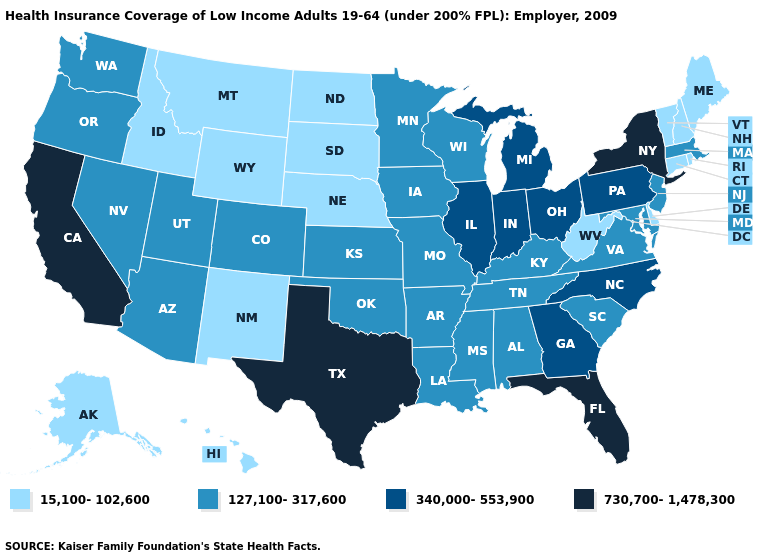Name the states that have a value in the range 730,700-1,478,300?
Be succinct. California, Florida, New York, Texas. What is the value of Mississippi?
Concise answer only. 127,100-317,600. Name the states that have a value in the range 730,700-1,478,300?
Quick response, please. California, Florida, New York, Texas. Which states have the lowest value in the USA?
Be succinct. Alaska, Connecticut, Delaware, Hawaii, Idaho, Maine, Montana, Nebraska, New Hampshire, New Mexico, North Dakota, Rhode Island, South Dakota, Vermont, West Virginia, Wyoming. Which states hav the highest value in the South?
Quick response, please. Florida, Texas. Among the states that border New Hampshire , which have the highest value?
Give a very brief answer. Massachusetts. Does Illinois have the highest value in the USA?
Keep it brief. No. What is the highest value in the South ?
Give a very brief answer. 730,700-1,478,300. What is the value of West Virginia?
Quick response, please. 15,100-102,600. What is the value of Alabama?
Short answer required. 127,100-317,600. What is the highest value in the USA?
Keep it brief. 730,700-1,478,300. Name the states that have a value in the range 127,100-317,600?
Be succinct. Alabama, Arizona, Arkansas, Colorado, Iowa, Kansas, Kentucky, Louisiana, Maryland, Massachusetts, Minnesota, Mississippi, Missouri, Nevada, New Jersey, Oklahoma, Oregon, South Carolina, Tennessee, Utah, Virginia, Washington, Wisconsin. Name the states that have a value in the range 15,100-102,600?
Write a very short answer. Alaska, Connecticut, Delaware, Hawaii, Idaho, Maine, Montana, Nebraska, New Hampshire, New Mexico, North Dakota, Rhode Island, South Dakota, Vermont, West Virginia, Wyoming. Name the states that have a value in the range 127,100-317,600?
Concise answer only. Alabama, Arizona, Arkansas, Colorado, Iowa, Kansas, Kentucky, Louisiana, Maryland, Massachusetts, Minnesota, Mississippi, Missouri, Nevada, New Jersey, Oklahoma, Oregon, South Carolina, Tennessee, Utah, Virginia, Washington, Wisconsin. What is the value of Maine?
Answer briefly. 15,100-102,600. 